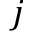<formula> <loc_0><loc_0><loc_500><loc_500>j</formula> 